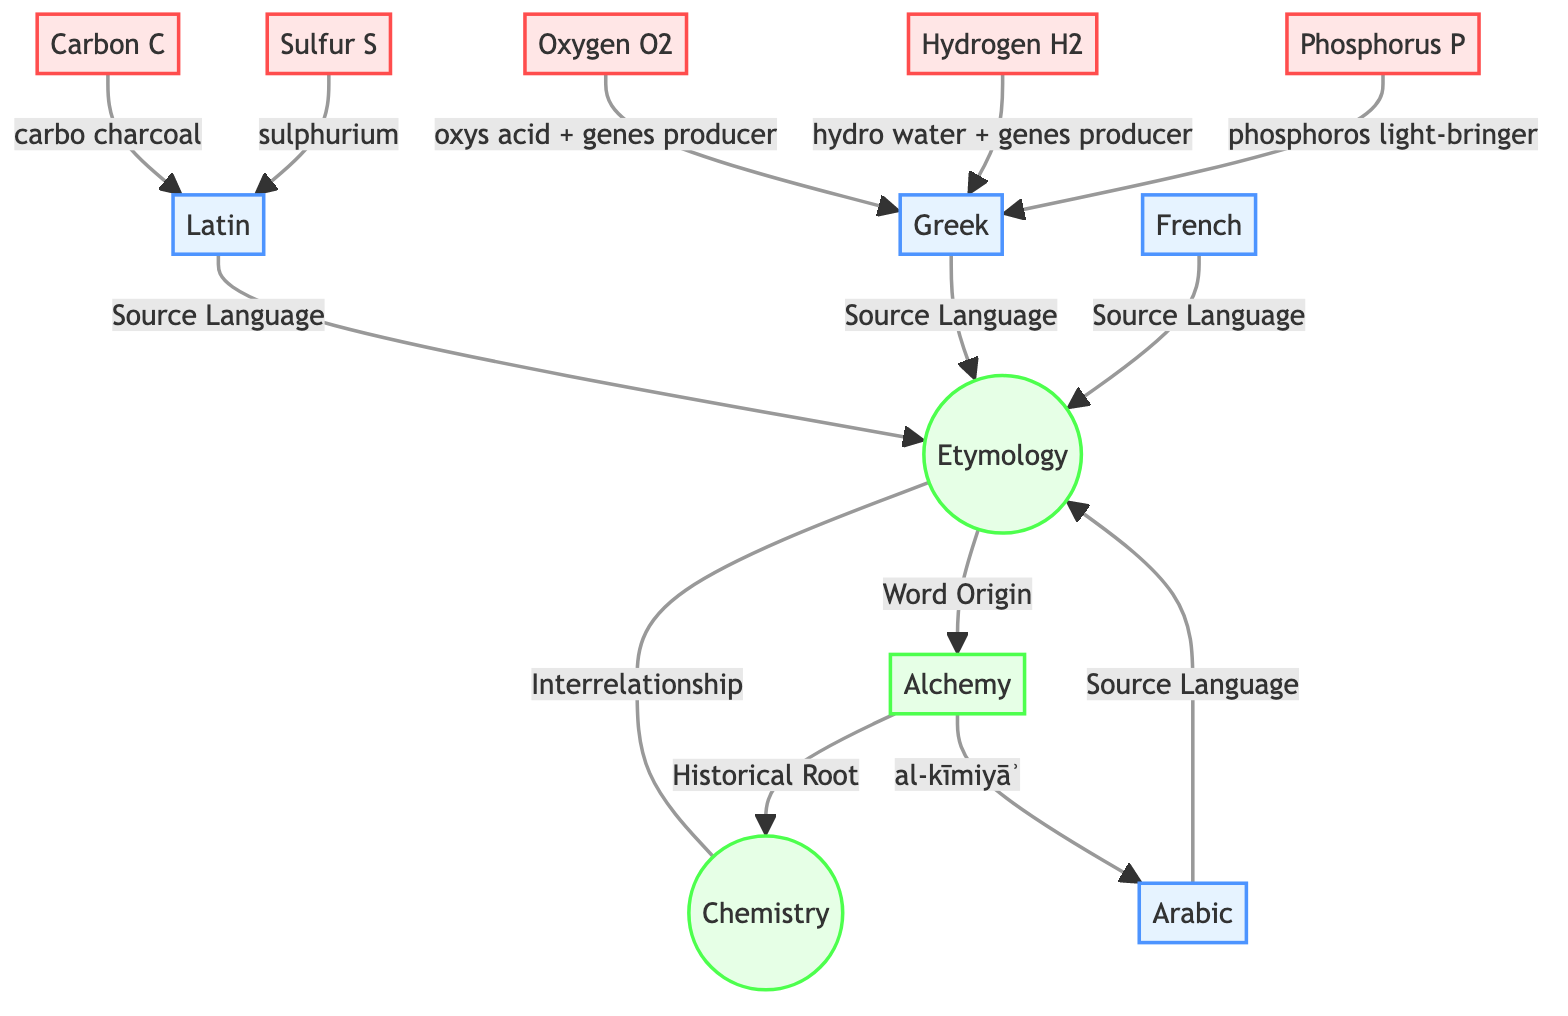What is the primary concept that connects etymology and chemistry? The diagram shows a direct connection labeled "Interrelationship" between the nodes "Etymology" and "Chemistry." This indicates that the primary concept connecting them is their interrelationship.
Answer: Interrelationship How many source languages are listed in the diagram? The diagram provides a total of four source languages: Latin, Greek, Arabic, and French. By counting these nodes, we can determine that there are four source languages.
Answer: 4 Which element's name originates from Arabic? Looking at the connections, "alchemy" is identified as the historical root of chemistry and has the label "al-kīmiyāʾ" connecting to Arabic in the diagram. Since "alchemy" is the only element linked to Arabic, this is the answer.
Answer: Alchemy What does the term 'hydrogen' mean according to its etymology in this diagram? The diagram indicates that 'hydrogen' is derived from the Greek words "hydro," meaning water, and "genes," meaning producer. Thus, the meaning of 'hydrogen' combines these two etymological components.
Answer: Water producer Which word origin is associated with carbon? The diagram specifies that 'carbon' comes from the Latin word "carbo," which means charcoal. Hence, this is the direct etymological connection stated in the diagram.
Answer: Carbo charcoal What is the historical root linking etymology and chemistry? The diagram shows a direct link from "alchemy" to "chemistry," indicating that 'alchemy' is the historical root that connects the study of etymology with chemistry, making it the correct answer.
Answer: Alchemy What is the etymological meaning of phosphorus according to the diagram? The diagram illustrates that 'phosphorus' comes from the Greek "phosphoros," which translates to "light-bringer." Therefore, the etymological meaning corresponds directly to this interpretation.
Answer: Light-bringer Which source language is associated with the element sulfur? Referring to the connections in the diagram, 'sulfur' is linked to the Latin word "sulphurium," which indicates that Latin is the source language connected to this element.
Answer: Latin What is the relationship between alchemy and chemistry shown in the diagram? The diagram illustrates a path labeled "Historical Root" that connects "alchemy" to "chemistry," suggesting that the relationship rests on alchemy's foundational influence on the development of modern chemistry.
Answer: Historical Root 